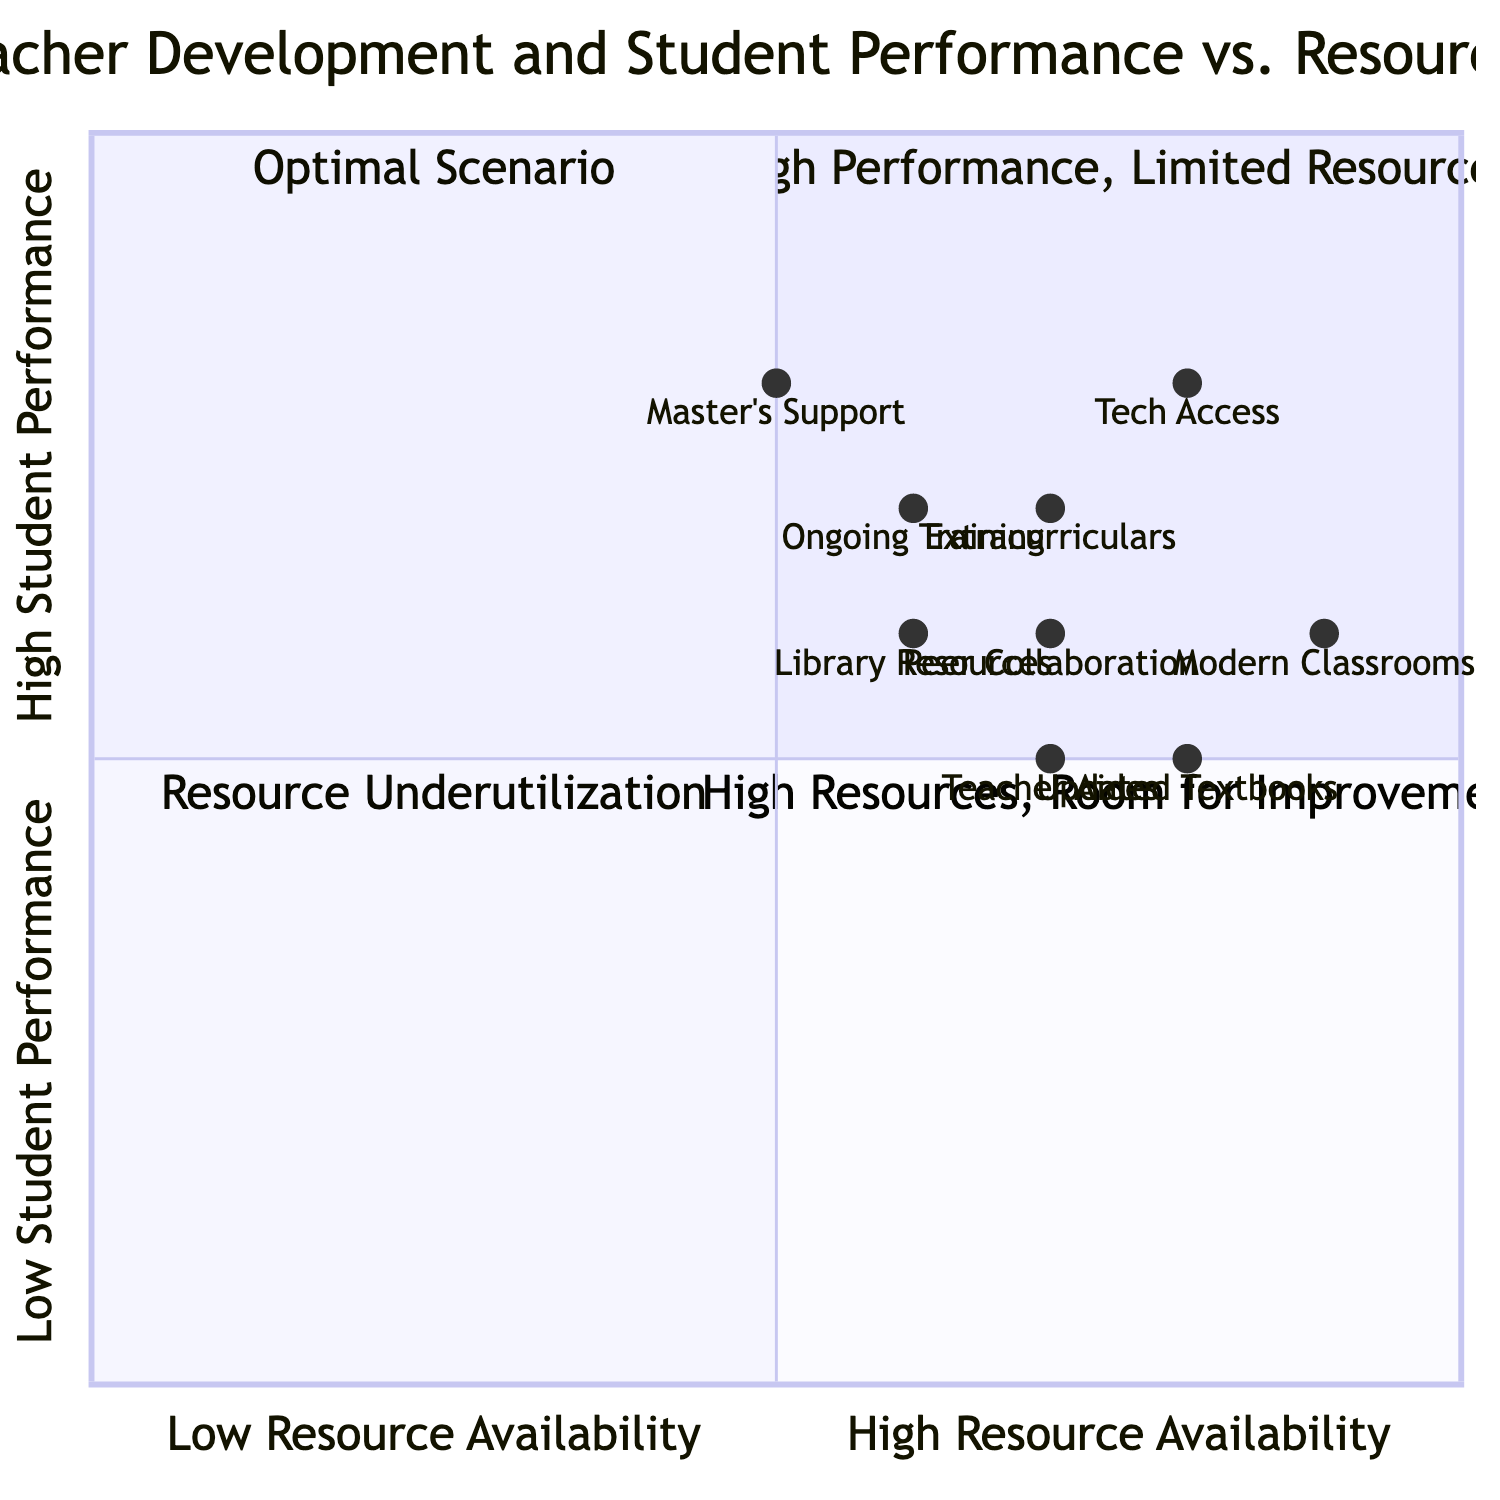What is the coordinate of "Ongoing Training" in the diagram? The coordinate for "Ongoing Training" is given as [0.6, 0.7], where 0.6 represents Low Resource Availability and 0.7 indicates High Student Performance on the y-axis.
Answer: [0.6, 0.7] In which quadrant does "Peer Collaboration" fall? "Peer Collaboration" has coordinates [0.7, 0.6], which places it in Quadrant 4, "High Resources, Room for Improvement," since it has High Resource Availability and Medium Student Performance.
Answer: Quadrant 4 What is the average student performance of resources in Quadrant 1? In Quadrant 1, the resource "Access to Technology" at [0.8, 0.8] qualifies, leading to an average performance of 0.8, indicating High Student Performance.
Answer: 0.8 How many resources are in Quadrant 3? The resources in Quadrant 3 are "Updated Textbooks" at [0.8, 0.5] and "Teacher Aides" at [0.7, 0.5], totaling 2 resources that have Low Student Performance.
Answer: 2 Which resource has the highest student performance? The resource "Master's Support" has a student performance coordinate of 0.8, which is the highest value when compared with other resources listed.
Answer: 0.8 What is the relationship between "Modern Classrooms" and student performance? "Modern Classrooms" with coordinates [0.9, 0.6] indicates that it has a High Resource Availability score of 0.9 but a Medium Student Performance score of 0.6, suggesting improvement potential.
Answer: Improvement potential Which program has the lowest resource availability score? The program "Master's Support" has the lowest resource availability score of 0.5 among its peers, indicating limited resources in that aspect.
Answer: 0.5 